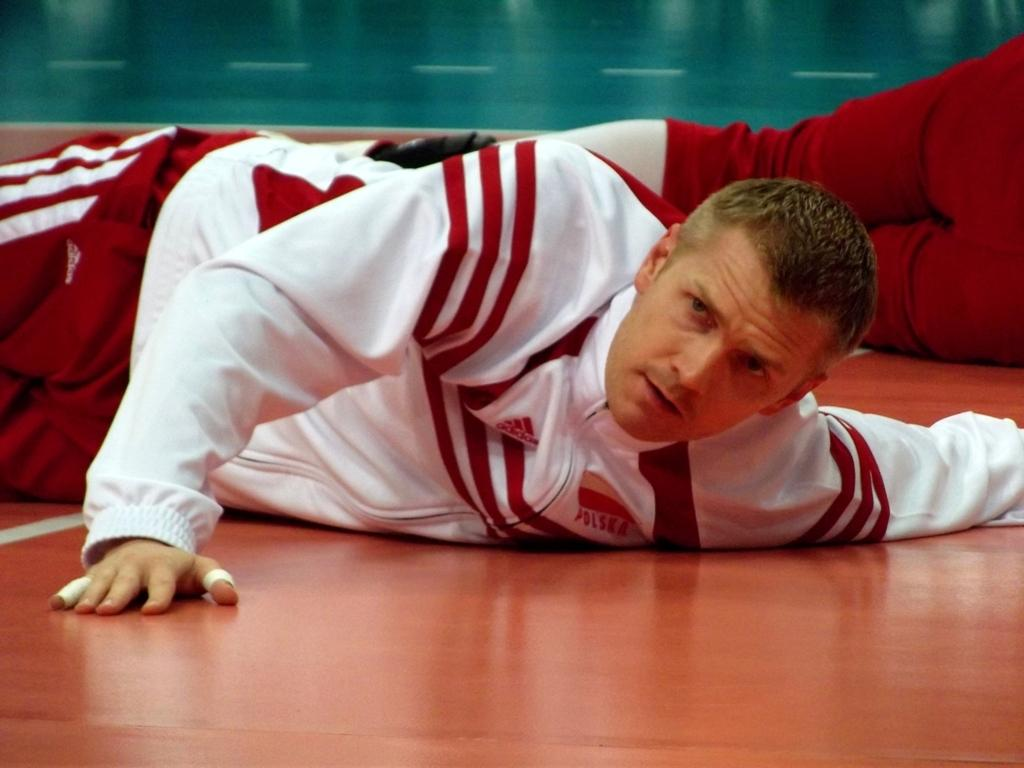How many people are in the image? There are two persons in the image. What are the two persons doing in the image? The two persons are lying on the floor. Where is the faucet located in the image? There is no faucet present in the image. What type of society is depicted in the image? The image does not depict a society; it only shows two persons lying on the floor. 